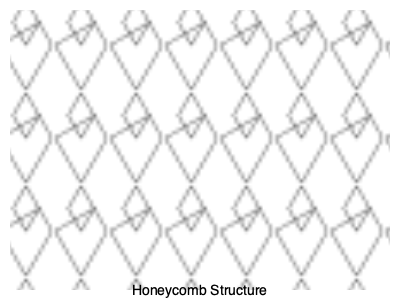In manufacturing processes inspired by natural structures, honeycomb patterns are often used for their structural integrity. Given a hexagonal grid with side length $a$, what is the ratio of the area of a single hexagon to its perimeter squared, and how does this relate to the structure's efficiency in terms of material usage and strength? To solve this problem, we'll follow these steps:

1. Calculate the area of a regular hexagon:
   The area of a regular hexagon is given by the formula:
   $$A = \frac{3\sqrt{3}}{2}a^2$$

2. Calculate the perimeter of the hexagon:
   The perimeter is simply six times the side length:
   $$P = 6a$$

3. Calculate the ratio of area to perimeter squared:
   $$\frac{A}{P^2} = \frac{\frac{3\sqrt{3}}{2}a^2}{(6a)^2} = \frac{\frac{3\sqrt{3}}{2}a^2}{36a^2} = \frac{\sqrt{3}}{24} \approx 0.0722$$

4. Interpret the result:
   This ratio is a dimensionless quantity that represents the efficiency of the structure in terms of area enclosed per unit of boundary material. A higher ratio indicates more efficient use of material.

5. Compare to other shapes:
   For a circle (the most efficient shape), this ratio is $\frac{1}{4\pi} \approx 0.0796$.
   For a square, it's $\frac{1}{16} = 0.0625$.

6. Relate to structural integrity:
   The hexagonal structure closely approaches the efficiency of a circle while providing a tessellating pattern that can fill a plane without gaps. This combination of material efficiency and ability to create a continuous structure contributes to its high structural integrity.

7. Biological relevance:
   In nature, this structure is seen in beehives, where it provides maximum storage space with minimum material use. This efficient use of resources is crucial in biological systems and can be applied to manufacturing processes to optimize material use and structural strength.
Answer: $\frac{\sqrt{3}}{24} \approx 0.0722$; near-optimal material efficiency and high structural integrity 